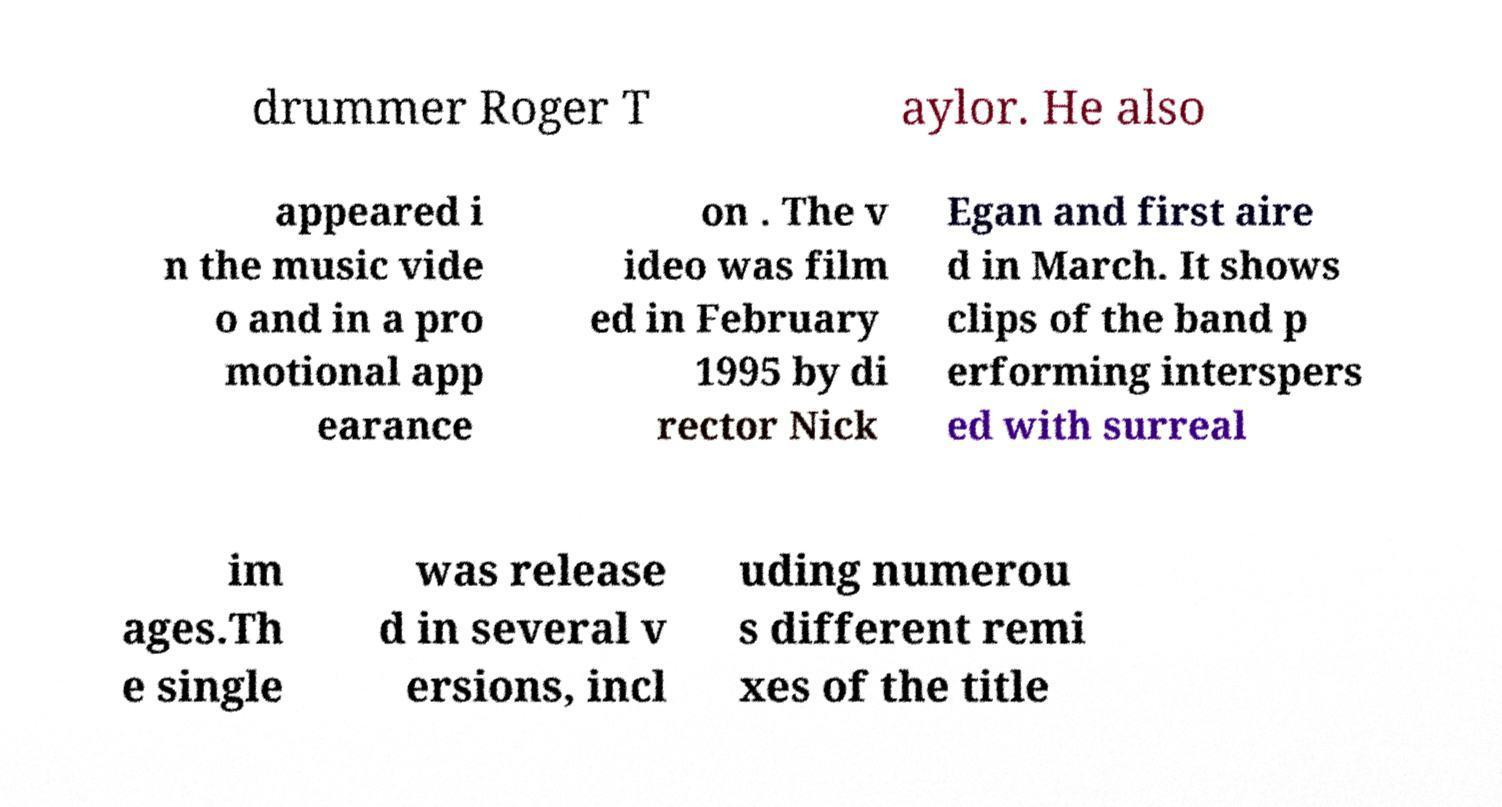Can you read and provide the text displayed in the image?This photo seems to have some interesting text. Can you extract and type it out for me? drummer Roger T aylor. He also appeared i n the music vide o and in a pro motional app earance on . The v ideo was film ed in February 1995 by di rector Nick Egan and first aire d in March. It shows clips of the band p erforming interspers ed with surreal im ages.Th e single was release d in several v ersions, incl uding numerou s different remi xes of the title 